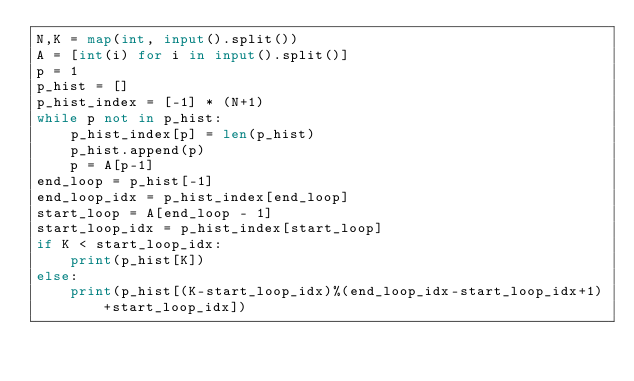Convert code to text. <code><loc_0><loc_0><loc_500><loc_500><_Python_>N,K = map(int, input().split())
A = [int(i) for i in input().split()]
p = 1
p_hist = []
p_hist_index = [-1] * (N+1)
while p not in p_hist:
    p_hist_index[p] = len(p_hist)
    p_hist.append(p)
    p = A[p-1]
end_loop = p_hist[-1]
end_loop_idx = p_hist_index[end_loop]
start_loop = A[end_loop - 1]
start_loop_idx = p_hist_index[start_loop]
if K < start_loop_idx:
    print(p_hist[K])
else:
    print(p_hist[(K-start_loop_idx)%(end_loop_idx-start_loop_idx+1)+start_loop_idx])
</code> 